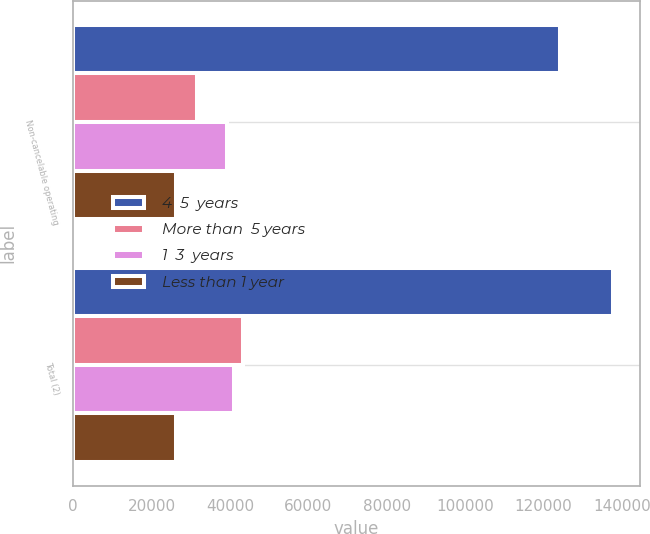Convert chart. <chart><loc_0><loc_0><loc_500><loc_500><stacked_bar_chart><ecel><fcel>Non-cancelable operating<fcel>Total (2)<nl><fcel>4  5  years<fcel>124076<fcel>137655<nl><fcel>More than  5 years<fcel>31595<fcel>43210<nl><fcel>1  3  years<fcel>39148<fcel>41107<nl><fcel>Less than 1 year<fcel>26182<fcel>26187<nl></chart> 